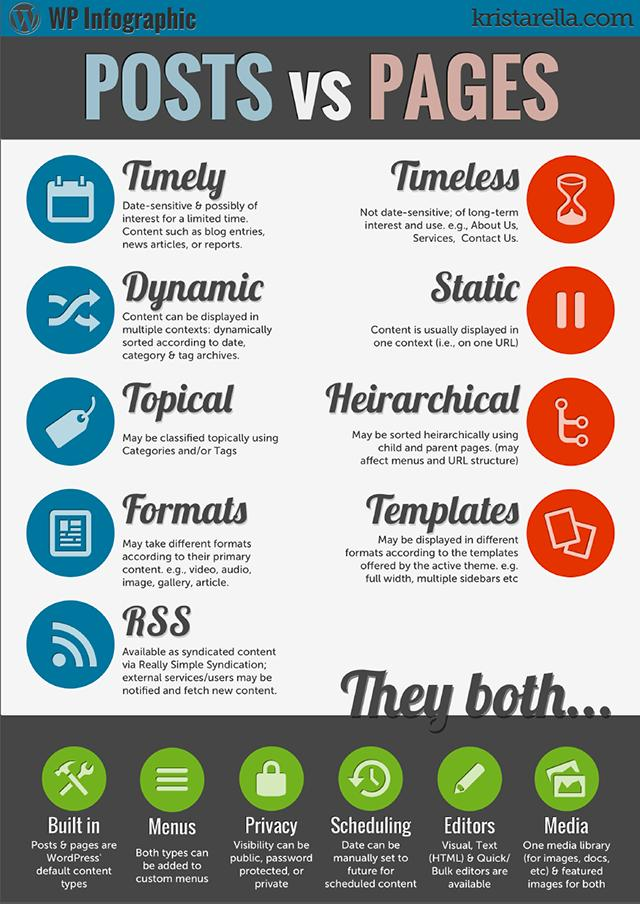Indicate a few pertinent items in this graphic. There are options for visibility of pages and posts including public, password-protected, and private. RSS stands for Really Simple Syndication, which is a format for distributing and gathering web content. 